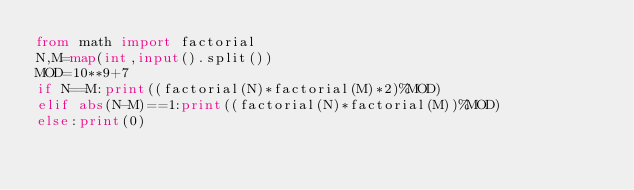Convert code to text. <code><loc_0><loc_0><loc_500><loc_500><_Python_>from math import factorial
N,M=map(int,input().split())
MOD=10**9+7
if N==M:print((factorial(N)*factorial(M)*2)%MOD)
elif abs(N-M)==1:print((factorial(N)*factorial(M))%MOD)
else:print(0)</code> 